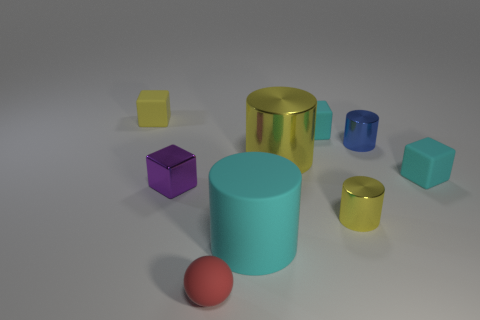Add 1 small rubber objects. How many objects exist? 10 Subtract all blocks. How many objects are left? 5 Subtract 0 brown blocks. How many objects are left? 9 Subtract all metal things. Subtract all big green cylinders. How many objects are left? 5 Add 1 small blocks. How many small blocks are left? 5 Add 2 small purple metal blocks. How many small purple metal blocks exist? 3 